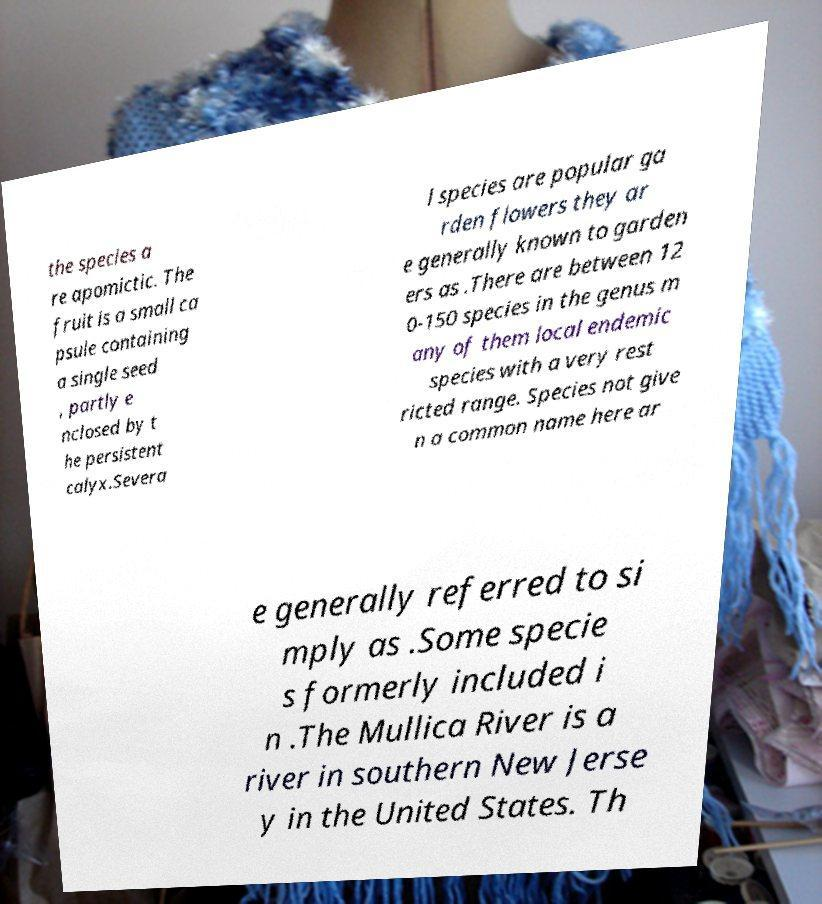Please read and relay the text visible in this image. What does it say? the species a re apomictic. The fruit is a small ca psule containing a single seed , partly e nclosed by t he persistent calyx.Severa l species are popular ga rden flowers they ar e generally known to garden ers as .There are between 12 0-150 species in the genus m any of them local endemic species with a very rest ricted range. Species not give n a common name here ar e generally referred to si mply as .Some specie s formerly included i n .The Mullica River is a river in southern New Jerse y in the United States. Th 